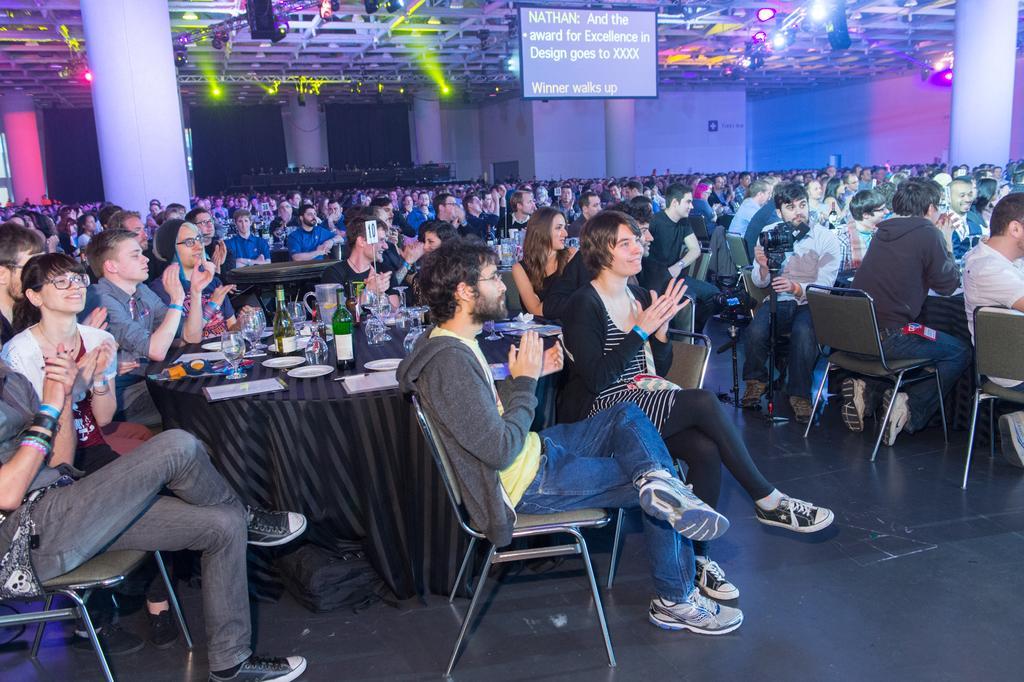Please provide a concise description of this image. In this picture there are group of people sitting on the chair. There is a glass, bottle , plate, pen and other objects on the table. There are some lights on the top and a screen. 